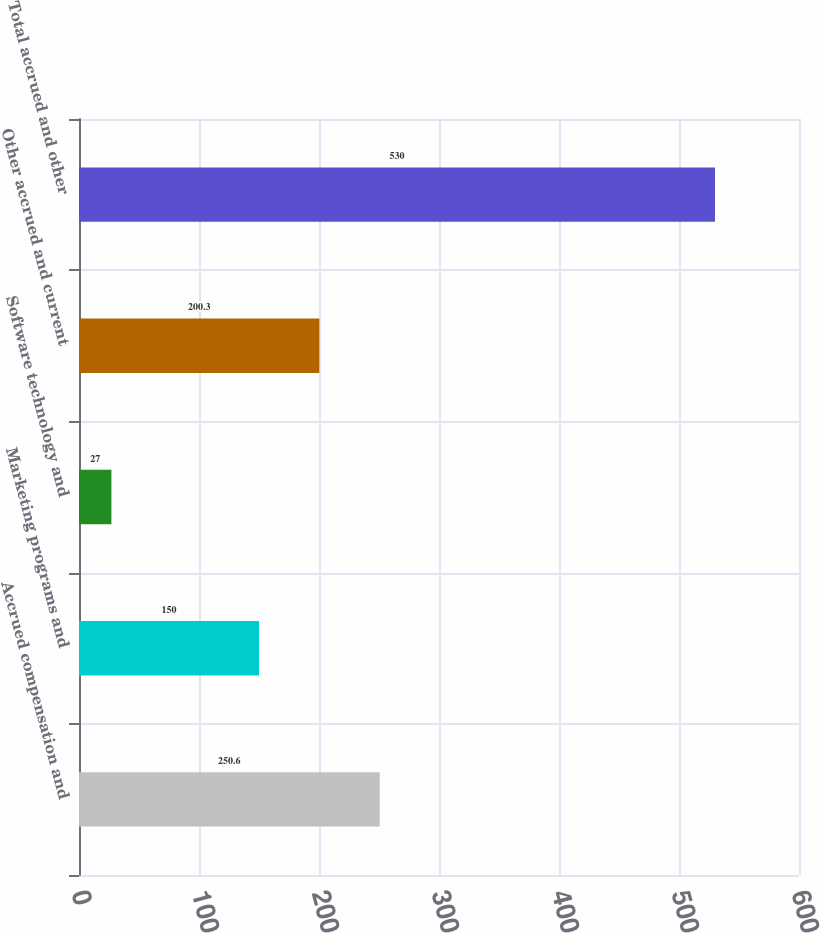Convert chart. <chart><loc_0><loc_0><loc_500><loc_500><bar_chart><fcel>Accrued compensation and<fcel>Marketing programs and<fcel>Software technology and<fcel>Other accrued and current<fcel>Total accrued and other<nl><fcel>250.6<fcel>150<fcel>27<fcel>200.3<fcel>530<nl></chart> 